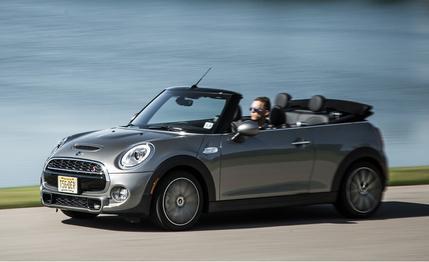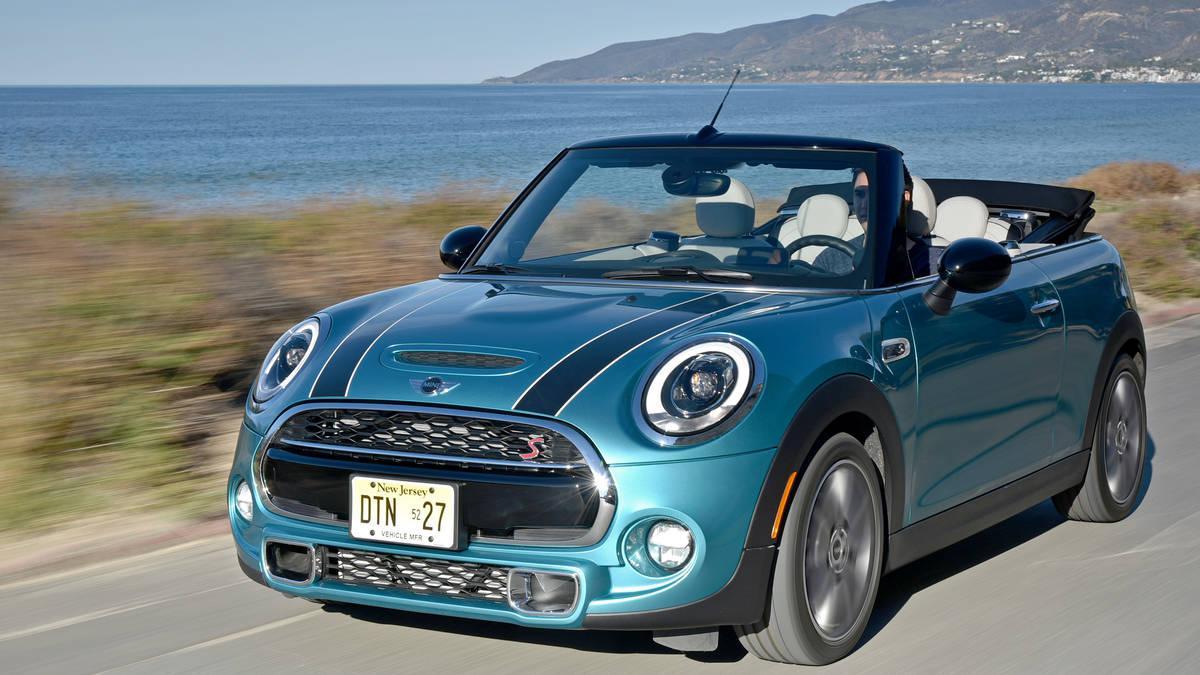The first image is the image on the left, the second image is the image on the right. For the images shown, is this caption "Each image contains one forward-angled car with its top down and a driver behind the wheel." true? Answer yes or no. Yes. 